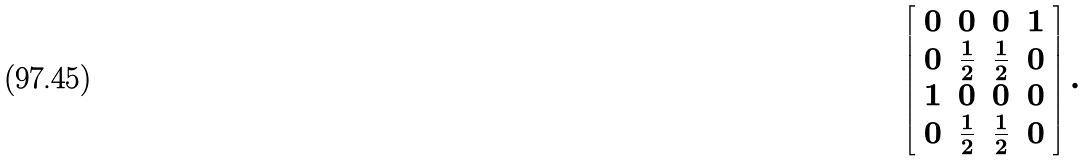Convert formula to latex. <formula><loc_0><loc_0><loc_500><loc_500>\left [ \begin{array} { c c c c } 0 & 0 & 0 & 1 \\ 0 & \frac { 1 } { 2 } & \frac { 1 } { 2 } & 0 \\ 1 & 0 & 0 & 0 \\ 0 & \frac { 1 } { 2 } & \frac { 1 } { 2 } & 0 \end{array} \right ] .</formula> 